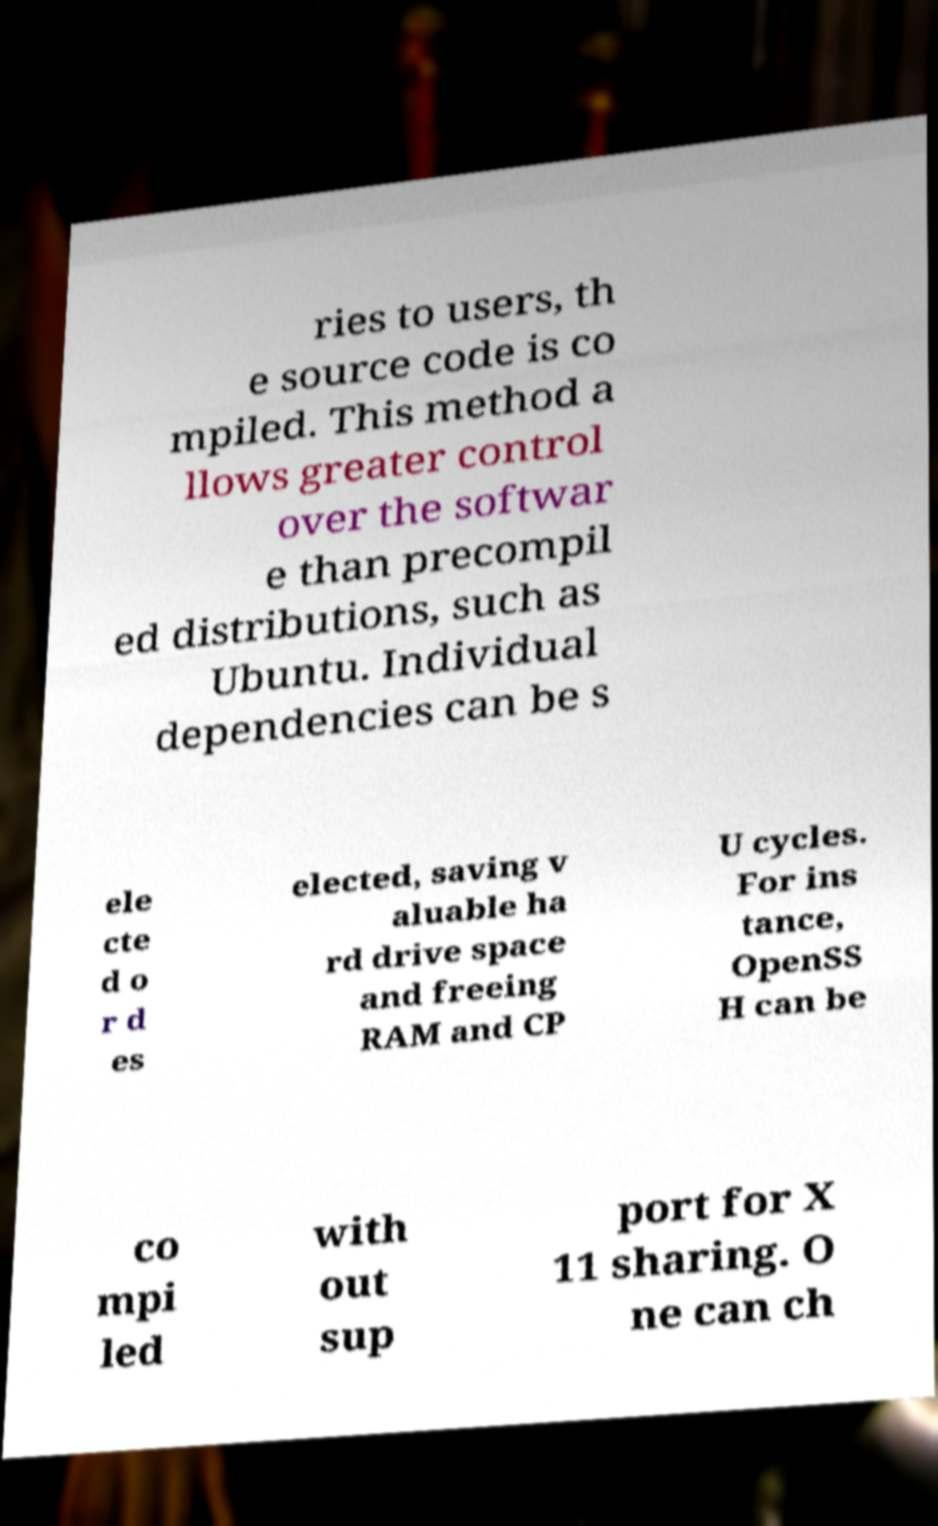I need the written content from this picture converted into text. Can you do that? ries to users, th e source code is co mpiled. This method a llows greater control over the softwar e than precompil ed distributions, such as Ubuntu. Individual dependencies can be s ele cte d o r d es elected, saving v aluable ha rd drive space and freeing RAM and CP U cycles. For ins tance, OpenSS H can be co mpi led with out sup port for X 11 sharing. O ne can ch 